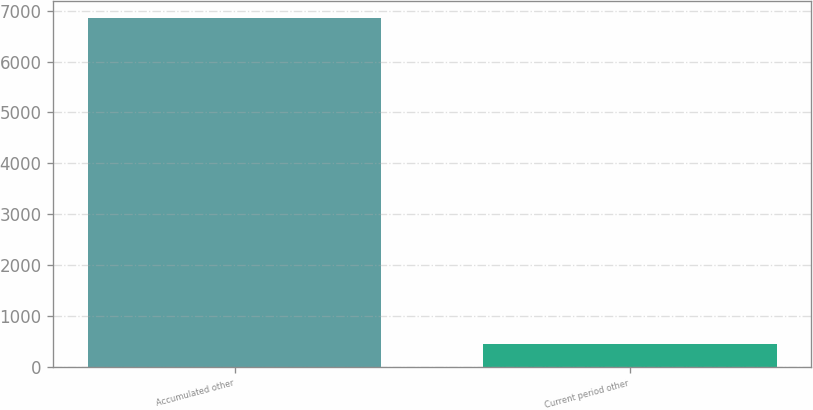<chart> <loc_0><loc_0><loc_500><loc_500><bar_chart><fcel>Accumulated other<fcel>Current period other<nl><fcel>6855<fcel>458<nl></chart> 